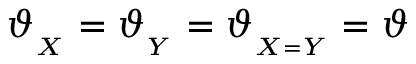Convert formula to latex. <formula><loc_0><loc_0><loc_500><loc_500>\vartheta _ { _ { X } } = \vartheta _ { _ { Y } } = \vartheta _ { _ { X = Y } } = \vartheta</formula> 